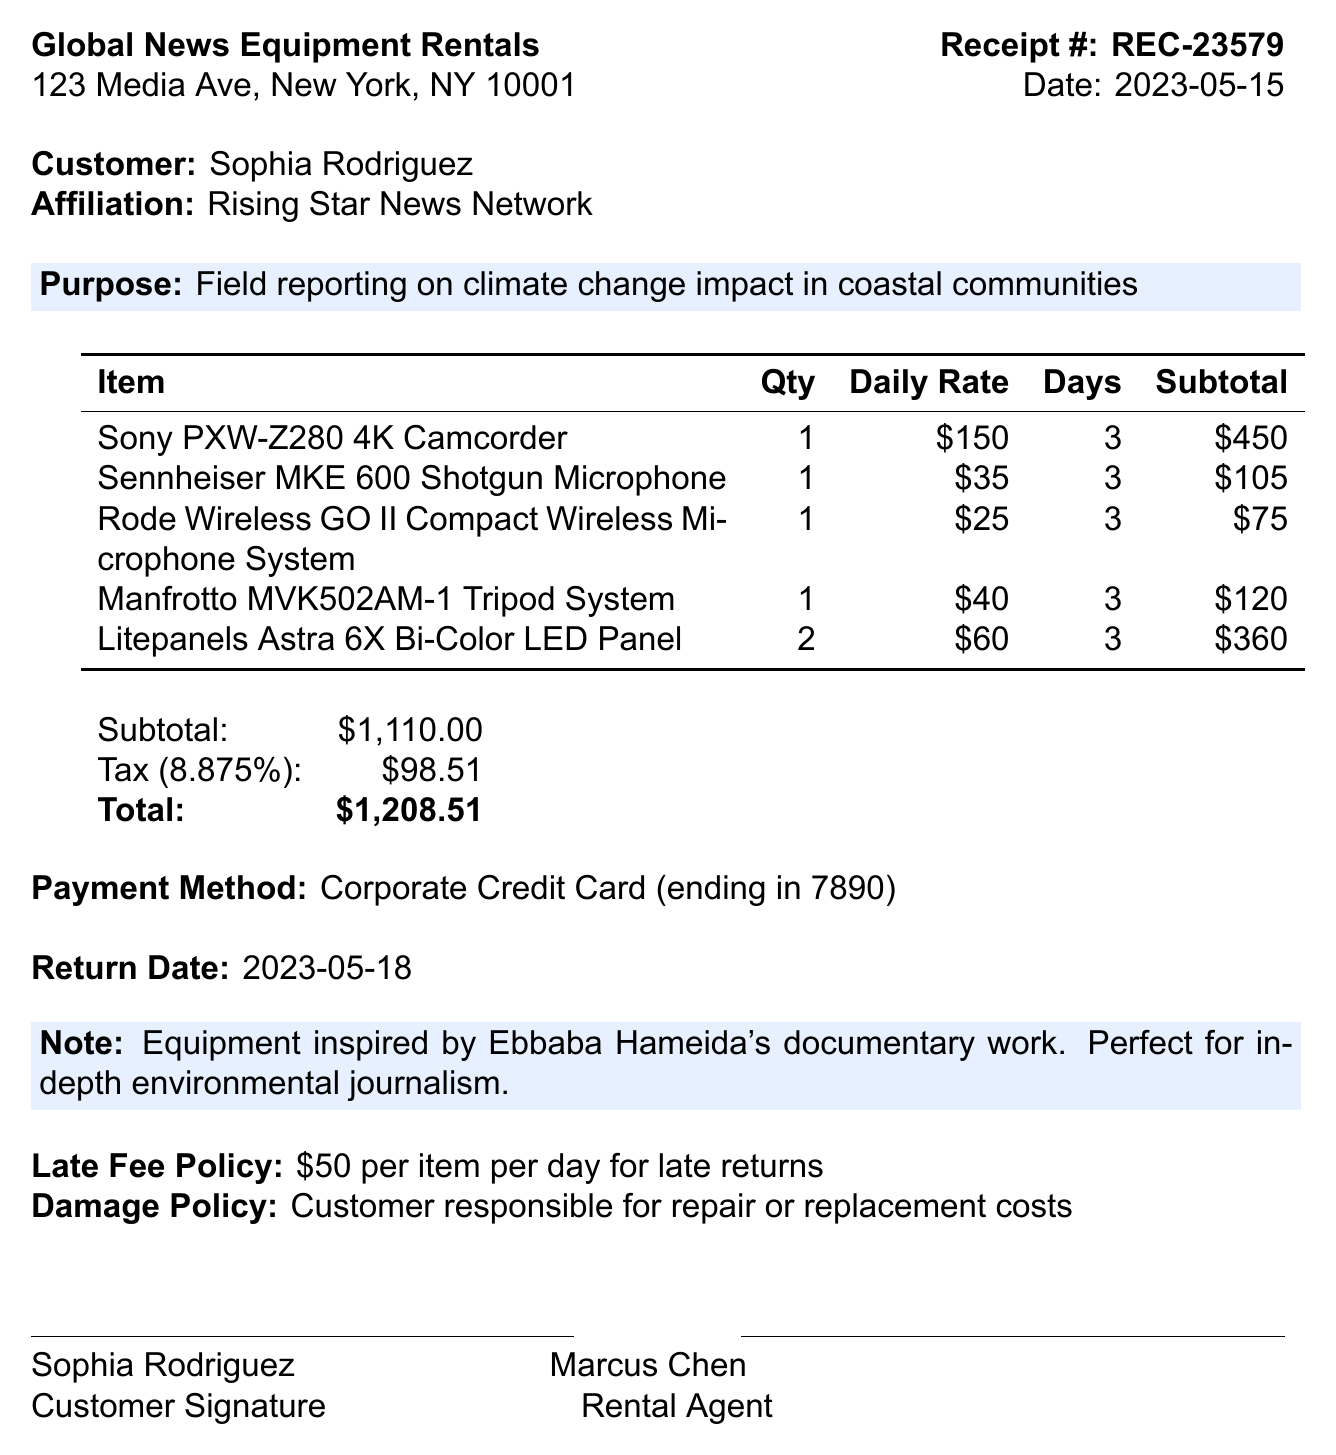What is the receipt number? The receipt number is a unique identifier for this transaction, listed prominently in the document.
Answer: REC-23579 What is the total amount due? The total amount due is the final cost after adding the tax to the subtotal.
Answer: $1,208.51 Who is the customer? The customer's name is provided near the top of the document, identifying the individual responsible for the rental.
Answer: Sophia Rodriguez What is the rental purpose? The purpose of the rental is specified to indicate the intended use of the equipment for reporting.
Answer: Field reporting on climate change impact in coastal communities How many Litepanels Astra 6X Bi-Color LED Panels were rented? The quantity of each item rented is detailed in the rental items section.
Answer: 2 What is the tax rate applied? The tax rate affects the calculation of tax added to the subtotal; it is stated explicitly in the document.
Answer: 8.875% What is the return date for the equipment? The return date is provided for the customer to know when the equipment should be returned.
Answer: 2023-05-18 Who is the rental agent? The rental agent's name is included at the bottom of the document alongside the customer signature, indicating who facilitated the rental.
Answer: Marcus Chen What is the damage policy? The damage policy outlines the responsibilities of the customer regarding any damage to the rented equipment.
Answer: Customer responsible for repair or replacement costs 